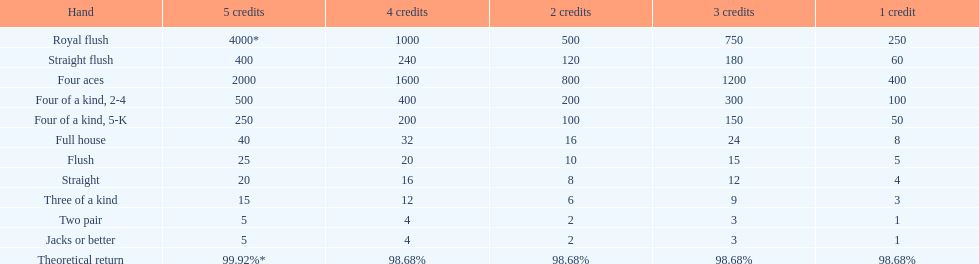What is the combined value of a 3-credit straight flush? 180. 